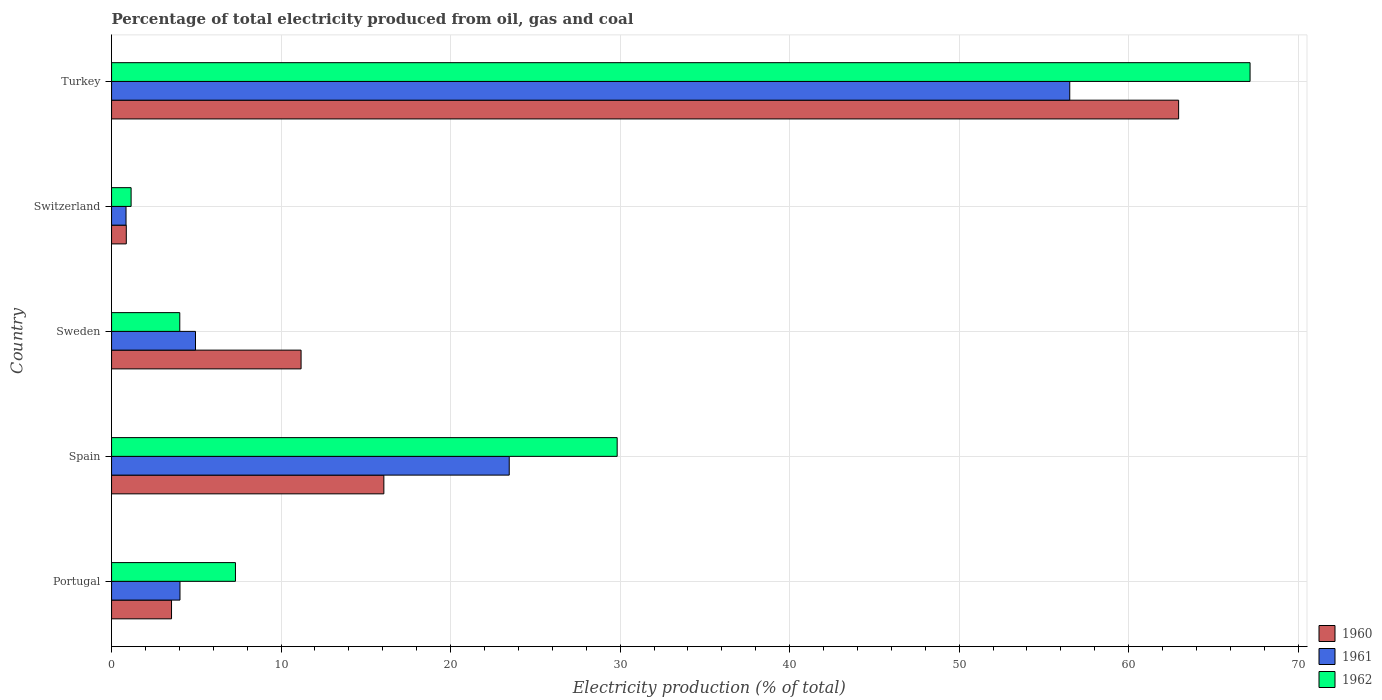How many different coloured bars are there?
Offer a terse response. 3. Are the number of bars per tick equal to the number of legend labels?
Provide a succinct answer. Yes. How many bars are there on the 4th tick from the top?
Your answer should be compact. 3. How many bars are there on the 1st tick from the bottom?
Provide a short and direct response. 3. What is the label of the 3rd group of bars from the top?
Give a very brief answer. Sweden. What is the electricity production in in 1961 in Switzerland?
Ensure brevity in your answer.  0.85. Across all countries, what is the maximum electricity production in in 1961?
Your answer should be compact. 56.53. Across all countries, what is the minimum electricity production in in 1962?
Provide a short and direct response. 1.15. In which country was the electricity production in in 1962 maximum?
Provide a succinct answer. Turkey. In which country was the electricity production in in 1960 minimum?
Your answer should be very brief. Switzerland. What is the total electricity production in in 1961 in the graph?
Make the answer very short. 89.83. What is the difference between the electricity production in in 1960 in Spain and that in Switzerland?
Offer a very short reply. 15.19. What is the difference between the electricity production in in 1962 in Switzerland and the electricity production in in 1961 in Sweden?
Your response must be concise. -3.8. What is the average electricity production in in 1962 per country?
Ensure brevity in your answer.  21.9. What is the difference between the electricity production in in 1961 and electricity production in in 1960 in Turkey?
Make the answer very short. -6.42. What is the ratio of the electricity production in in 1962 in Switzerland to that in Turkey?
Provide a short and direct response. 0.02. Is the electricity production in in 1961 in Spain less than that in Sweden?
Keep it short and to the point. No. Is the difference between the electricity production in in 1961 in Sweden and Turkey greater than the difference between the electricity production in in 1960 in Sweden and Turkey?
Offer a terse response. Yes. What is the difference between the highest and the second highest electricity production in in 1960?
Offer a terse response. 46.89. What is the difference between the highest and the lowest electricity production in in 1962?
Offer a very short reply. 66.01. Is the sum of the electricity production in in 1961 in Sweden and Switzerland greater than the maximum electricity production in in 1960 across all countries?
Provide a short and direct response. No. What does the 1st bar from the top in Switzerland represents?
Make the answer very short. 1962. Are all the bars in the graph horizontal?
Give a very brief answer. Yes. What is the difference between two consecutive major ticks on the X-axis?
Your answer should be compact. 10. Are the values on the major ticks of X-axis written in scientific E-notation?
Give a very brief answer. No. Does the graph contain grids?
Keep it short and to the point. Yes. Where does the legend appear in the graph?
Make the answer very short. Bottom right. What is the title of the graph?
Your response must be concise. Percentage of total electricity produced from oil, gas and coal. Does "1965" appear as one of the legend labels in the graph?
Your answer should be compact. No. What is the label or title of the X-axis?
Your answer should be very brief. Electricity production (% of total). What is the Electricity production (% of total) of 1960 in Portugal?
Make the answer very short. 3.54. What is the Electricity production (% of total) of 1961 in Portugal?
Keep it short and to the point. 4.04. What is the Electricity production (% of total) in 1962 in Portugal?
Make the answer very short. 7.31. What is the Electricity production (% of total) of 1960 in Spain?
Your answer should be compact. 16.06. What is the Electricity production (% of total) of 1961 in Spain?
Your answer should be very brief. 23.46. What is the Electricity production (% of total) in 1962 in Spain?
Your answer should be compact. 29.83. What is the Electricity production (% of total) of 1960 in Sweden?
Your response must be concise. 11.18. What is the Electricity production (% of total) in 1961 in Sweden?
Your answer should be compact. 4.95. What is the Electricity production (% of total) in 1962 in Sweden?
Keep it short and to the point. 4.02. What is the Electricity production (% of total) of 1960 in Switzerland?
Offer a terse response. 0.87. What is the Electricity production (% of total) in 1961 in Switzerland?
Give a very brief answer. 0.85. What is the Electricity production (% of total) in 1962 in Switzerland?
Provide a short and direct response. 1.15. What is the Electricity production (% of total) of 1960 in Turkey?
Provide a short and direct response. 62.95. What is the Electricity production (% of total) of 1961 in Turkey?
Your response must be concise. 56.53. What is the Electricity production (% of total) of 1962 in Turkey?
Make the answer very short. 67.16. Across all countries, what is the maximum Electricity production (% of total) of 1960?
Provide a short and direct response. 62.95. Across all countries, what is the maximum Electricity production (% of total) in 1961?
Provide a succinct answer. 56.53. Across all countries, what is the maximum Electricity production (% of total) of 1962?
Offer a very short reply. 67.16. Across all countries, what is the minimum Electricity production (% of total) in 1960?
Your response must be concise. 0.87. Across all countries, what is the minimum Electricity production (% of total) in 1961?
Provide a succinct answer. 0.85. Across all countries, what is the minimum Electricity production (% of total) in 1962?
Ensure brevity in your answer.  1.15. What is the total Electricity production (% of total) in 1960 in the graph?
Provide a short and direct response. 94.6. What is the total Electricity production (% of total) of 1961 in the graph?
Ensure brevity in your answer.  89.83. What is the total Electricity production (% of total) of 1962 in the graph?
Provide a short and direct response. 109.48. What is the difference between the Electricity production (% of total) of 1960 in Portugal and that in Spain?
Keep it short and to the point. -12.53. What is the difference between the Electricity production (% of total) in 1961 in Portugal and that in Spain?
Provide a succinct answer. -19.42. What is the difference between the Electricity production (% of total) in 1962 in Portugal and that in Spain?
Your answer should be very brief. -22.52. What is the difference between the Electricity production (% of total) in 1960 in Portugal and that in Sweden?
Offer a very short reply. -7.64. What is the difference between the Electricity production (% of total) of 1961 in Portugal and that in Sweden?
Offer a terse response. -0.92. What is the difference between the Electricity production (% of total) of 1962 in Portugal and that in Sweden?
Make the answer very short. 3.28. What is the difference between the Electricity production (% of total) in 1960 in Portugal and that in Switzerland?
Your response must be concise. 2.67. What is the difference between the Electricity production (% of total) in 1961 in Portugal and that in Switzerland?
Your response must be concise. 3.18. What is the difference between the Electricity production (% of total) in 1962 in Portugal and that in Switzerland?
Your response must be concise. 6.16. What is the difference between the Electricity production (% of total) of 1960 in Portugal and that in Turkey?
Make the answer very short. -59.41. What is the difference between the Electricity production (% of total) of 1961 in Portugal and that in Turkey?
Your answer should be very brief. -52.49. What is the difference between the Electricity production (% of total) in 1962 in Portugal and that in Turkey?
Your answer should be very brief. -59.85. What is the difference between the Electricity production (% of total) in 1960 in Spain and that in Sweden?
Provide a succinct answer. 4.88. What is the difference between the Electricity production (% of total) of 1961 in Spain and that in Sweden?
Give a very brief answer. 18.51. What is the difference between the Electricity production (% of total) in 1962 in Spain and that in Sweden?
Provide a succinct answer. 25.8. What is the difference between the Electricity production (% of total) of 1960 in Spain and that in Switzerland?
Offer a terse response. 15.19. What is the difference between the Electricity production (% of total) in 1961 in Spain and that in Switzerland?
Your answer should be very brief. 22.61. What is the difference between the Electricity production (% of total) in 1962 in Spain and that in Switzerland?
Provide a short and direct response. 28.67. What is the difference between the Electricity production (% of total) in 1960 in Spain and that in Turkey?
Your answer should be compact. -46.89. What is the difference between the Electricity production (% of total) of 1961 in Spain and that in Turkey?
Offer a very short reply. -33.07. What is the difference between the Electricity production (% of total) of 1962 in Spain and that in Turkey?
Provide a short and direct response. -37.34. What is the difference between the Electricity production (% of total) in 1960 in Sweden and that in Switzerland?
Ensure brevity in your answer.  10.31. What is the difference between the Electricity production (% of total) of 1961 in Sweden and that in Switzerland?
Provide a short and direct response. 4.1. What is the difference between the Electricity production (% of total) of 1962 in Sweden and that in Switzerland?
Provide a succinct answer. 2.87. What is the difference between the Electricity production (% of total) of 1960 in Sweden and that in Turkey?
Ensure brevity in your answer.  -51.77. What is the difference between the Electricity production (% of total) in 1961 in Sweden and that in Turkey?
Provide a succinct answer. -51.57. What is the difference between the Electricity production (% of total) in 1962 in Sweden and that in Turkey?
Provide a succinct answer. -63.14. What is the difference between the Electricity production (% of total) in 1960 in Switzerland and that in Turkey?
Your answer should be very brief. -62.08. What is the difference between the Electricity production (% of total) in 1961 in Switzerland and that in Turkey?
Your response must be concise. -55.67. What is the difference between the Electricity production (% of total) of 1962 in Switzerland and that in Turkey?
Your answer should be compact. -66.01. What is the difference between the Electricity production (% of total) of 1960 in Portugal and the Electricity production (% of total) of 1961 in Spain?
Offer a terse response. -19.92. What is the difference between the Electricity production (% of total) in 1960 in Portugal and the Electricity production (% of total) in 1962 in Spain?
Your answer should be very brief. -26.29. What is the difference between the Electricity production (% of total) in 1961 in Portugal and the Electricity production (% of total) in 1962 in Spain?
Your answer should be compact. -25.79. What is the difference between the Electricity production (% of total) in 1960 in Portugal and the Electricity production (% of total) in 1961 in Sweden?
Your answer should be very brief. -1.41. What is the difference between the Electricity production (% of total) of 1960 in Portugal and the Electricity production (% of total) of 1962 in Sweden?
Your answer should be compact. -0.49. What is the difference between the Electricity production (% of total) in 1961 in Portugal and the Electricity production (% of total) in 1962 in Sweden?
Keep it short and to the point. 0.01. What is the difference between the Electricity production (% of total) of 1960 in Portugal and the Electricity production (% of total) of 1961 in Switzerland?
Ensure brevity in your answer.  2.68. What is the difference between the Electricity production (% of total) of 1960 in Portugal and the Electricity production (% of total) of 1962 in Switzerland?
Ensure brevity in your answer.  2.38. What is the difference between the Electricity production (% of total) in 1961 in Portugal and the Electricity production (% of total) in 1962 in Switzerland?
Your answer should be compact. 2.88. What is the difference between the Electricity production (% of total) in 1960 in Portugal and the Electricity production (% of total) in 1961 in Turkey?
Keep it short and to the point. -52.99. What is the difference between the Electricity production (% of total) in 1960 in Portugal and the Electricity production (% of total) in 1962 in Turkey?
Offer a very short reply. -63.63. What is the difference between the Electricity production (% of total) in 1961 in Portugal and the Electricity production (% of total) in 1962 in Turkey?
Give a very brief answer. -63.13. What is the difference between the Electricity production (% of total) in 1960 in Spain and the Electricity production (% of total) in 1961 in Sweden?
Provide a succinct answer. 11.11. What is the difference between the Electricity production (% of total) in 1960 in Spain and the Electricity production (% of total) in 1962 in Sweden?
Give a very brief answer. 12.04. What is the difference between the Electricity production (% of total) of 1961 in Spain and the Electricity production (% of total) of 1962 in Sweden?
Your answer should be compact. 19.44. What is the difference between the Electricity production (% of total) in 1960 in Spain and the Electricity production (% of total) in 1961 in Switzerland?
Your answer should be compact. 15.21. What is the difference between the Electricity production (% of total) in 1960 in Spain and the Electricity production (% of total) in 1962 in Switzerland?
Provide a succinct answer. 14.91. What is the difference between the Electricity production (% of total) in 1961 in Spain and the Electricity production (% of total) in 1962 in Switzerland?
Your answer should be very brief. 22.31. What is the difference between the Electricity production (% of total) of 1960 in Spain and the Electricity production (% of total) of 1961 in Turkey?
Provide a succinct answer. -40.46. What is the difference between the Electricity production (% of total) in 1960 in Spain and the Electricity production (% of total) in 1962 in Turkey?
Ensure brevity in your answer.  -51.1. What is the difference between the Electricity production (% of total) in 1961 in Spain and the Electricity production (% of total) in 1962 in Turkey?
Provide a short and direct response. -43.7. What is the difference between the Electricity production (% of total) in 1960 in Sweden and the Electricity production (% of total) in 1961 in Switzerland?
Your response must be concise. 10.33. What is the difference between the Electricity production (% of total) in 1960 in Sweden and the Electricity production (% of total) in 1962 in Switzerland?
Your answer should be very brief. 10.03. What is the difference between the Electricity production (% of total) of 1961 in Sweden and the Electricity production (% of total) of 1962 in Switzerland?
Give a very brief answer. 3.8. What is the difference between the Electricity production (% of total) of 1960 in Sweden and the Electricity production (% of total) of 1961 in Turkey?
Provide a short and direct response. -45.35. What is the difference between the Electricity production (% of total) in 1960 in Sweden and the Electricity production (% of total) in 1962 in Turkey?
Keep it short and to the point. -55.98. What is the difference between the Electricity production (% of total) in 1961 in Sweden and the Electricity production (% of total) in 1962 in Turkey?
Your response must be concise. -62.21. What is the difference between the Electricity production (% of total) of 1960 in Switzerland and the Electricity production (% of total) of 1961 in Turkey?
Your response must be concise. -55.66. What is the difference between the Electricity production (% of total) in 1960 in Switzerland and the Electricity production (% of total) in 1962 in Turkey?
Keep it short and to the point. -66.29. What is the difference between the Electricity production (% of total) in 1961 in Switzerland and the Electricity production (% of total) in 1962 in Turkey?
Provide a succinct answer. -66.31. What is the average Electricity production (% of total) of 1960 per country?
Your response must be concise. 18.92. What is the average Electricity production (% of total) in 1961 per country?
Your response must be concise. 17.97. What is the average Electricity production (% of total) of 1962 per country?
Provide a short and direct response. 21.9. What is the difference between the Electricity production (% of total) of 1960 and Electricity production (% of total) of 1961 in Portugal?
Ensure brevity in your answer.  -0.5. What is the difference between the Electricity production (% of total) of 1960 and Electricity production (% of total) of 1962 in Portugal?
Keep it short and to the point. -3.77. What is the difference between the Electricity production (% of total) of 1961 and Electricity production (% of total) of 1962 in Portugal?
Offer a terse response. -3.27. What is the difference between the Electricity production (% of total) of 1960 and Electricity production (% of total) of 1961 in Spain?
Provide a short and direct response. -7.4. What is the difference between the Electricity production (% of total) of 1960 and Electricity production (% of total) of 1962 in Spain?
Ensure brevity in your answer.  -13.76. What is the difference between the Electricity production (% of total) in 1961 and Electricity production (% of total) in 1962 in Spain?
Offer a terse response. -6.37. What is the difference between the Electricity production (% of total) of 1960 and Electricity production (% of total) of 1961 in Sweden?
Your response must be concise. 6.23. What is the difference between the Electricity production (% of total) of 1960 and Electricity production (% of total) of 1962 in Sweden?
Make the answer very short. 7.16. What is the difference between the Electricity production (% of total) in 1961 and Electricity production (% of total) in 1962 in Sweden?
Your answer should be compact. 0.93. What is the difference between the Electricity production (% of total) in 1960 and Electricity production (% of total) in 1961 in Switzerland?
Keep it short and to the point. 0.02. What is the difference between the Electricity production (% of total) of 1960 and Electricity production (% of total) of 1962 in Switzerland?
Your answer should be compact. -0.28. What is the difference between the Electricity production (% of total) in 1961 and Electricity production (% of total) in 1962 in Switzerland?
Ensure brevity in your answer.  -0.3. What is the difference between the Electricity production (% of total) of 1960 and Electricity production (% of total) of 1961 in Turkey?
Make the answer very short. 6.42. What is the difference between the Electricity production (% of total) in 1960 and Electricity production (% of total) in 1962 in Turkey?
Ensure brevity in your answer.  -4.21. What is the difference between the Electricity production (% of total) of 1961 and Electricity production (% of total) of 1962 in Turkey?
Keep it short and to the point. -10.64. What is the ratio of the Electricity production (% of total) in 1960 in Portugal to that in Spain?
Offer a very short reply. 0.22. What is the ratio of the Electricity production (% of total) in 1961 in Portugal to that in Spain?
Your response must be concise. 0.17. What is the ratio of the Electricity production (% of total) in 1962 in Portugal to that in Spain?
Your response must be concise. 0.24. What is the ratio of the Electricity production (% of total) of 1960 in Portugal to that in Sweden?
Offer a very short reply. 0.32. What is the ratio of the Electricity production (% of total) of 1961 in Portugal to that in Sweden?
Offer a very short reply. 0.82. What is the ratio of the Electricity production (% of total) of 1962 in Portugal to that in Sweden?
Ensure brevity in your answer.  1.82. What is the ratio of the Electricity production (% of total) in 1960 in Portugal to that in Switzerland?
Your answer should be very brief. 4.07. What is the ratio of the Electricity production (% of total) of 1961 in Portugal to that in Switzerland?
Make the answer very short. 4.73. What is the ratio of the Electricity production (% of total) in 1962 in Portugal to that in Switzerland?
Your response must be concise. 6.34. What is the ratio of the Electricity production (% of total) of 1960 in Portugal to that in Turkey?
Offer a very short reply. 0.06. What is the ratio of the Electricity production (% of total) in 1961 in Portugal to that in Turkey?
Your answer should be very brief. 0.07. What is the ratio of the Electricity production (% of total) in 1962 in Portugal to that in Turkey?
Offer a terse response. 0.11. What is the ratio of the Electricity production (% of total) of 1960 in Spain to that in Sweden?
Your answer should be very brief. 1.44. What is the ratio of the Electricity production (% of total) of 1961 in Spain to that in Sweden?
Your answer should be compact. 4.74. What is the ratio of the Electricity production (% of total) of 1962 in Spain to that in Sweden?
Provide a short and direct response. 7.41. What is the ratio of the Electricity production (% of total) in 1960 in Spain to that in Switzerland?
Your response must be concise. 18.47. What is the ratio of the Electricity production (% of total) of 1961 in Spain to that in Switzerland?
Ensure brevity in your answer.  27.48. What is the ratio of the Electricity production (% of total) in 1962 in Spain to that in Switzerland?
Provide a short and direct response. 25.86. What is the ratio of the Electricity production (% of total) in 1960 in Spain to that in Turkey?
Keep it short and to the point. 0.26. What is the ratio of the Electricity production (% of total) of 1961 in Spain to that in Turkey?
Offer a terse response. 0.41. What is the ratio of the Electricity production (% of total) in 1962 in Spain to that in Turkey?
Offer a terse response. 0.44. What is the ratio of the Electricity production (% of total) of 1960 in Sweden to that in Switzerland?
Keep it short and to the point. 12.86. What is the ratio of the Electricity production (% of total) of 1961 in Sweden to that in Switzerland?
Make the answer very short. 5.8. What is the ratio of the Electricity production (% of total) of 1962 in Sweden to that in Switzerland?
Make the answer very short. 3.49. What is the ratio of the Electricity production (% of total) of 1960 in Sweden to that in Turkey?
Your response must be concise. 0.18. What is the ratio of the Electricity production (% of total) of 1961 in Sweden to that in Turkey?
Keep it short and to the point. 0.09. What is the ratio of the Electricity production (% of total) of 1962 in Sweden to that in Turkey?
Your answer should be compact. 0.06. What is the ratio of the Electricity production (% of total) of 1960 in Switzerland to that in Turkey?
Offer a very short reply. 0.01. What is the ratio of the Electricity production (% of total) in 1961 in Switzerland to that in Turkey?
Your response must be concise. 0.02. What is the ratio of the Electricity production (% of total) of 1962 in Switzerland to that in Turkey?
Give a very brief answer. 0.02. What is the difference between the highest and the second highest Electricity production (% of total) of 1960?
Make the answer very short. 46.89. What is the difference between the highest and the second highest Electricity production (% of total) in 1961?
Offer a very short reply. 33.07. What is the difference between the highest and the second highest Electricity production (% of total) of 1962?
Ensure brevity in your answer.  37.34. What is the difference between the highest and the lowest Electricity production (% of total) of 1960?
Your response must be concise. 62.08. What is the difference between the highest and the lowest Electricity production (% of total) of 1961?
Make the answer very short. 55.67. What is the difference between the highest and the lowest Electricity production (% of total) of 1962?
Ensure brevity in your answer.  66.01. 